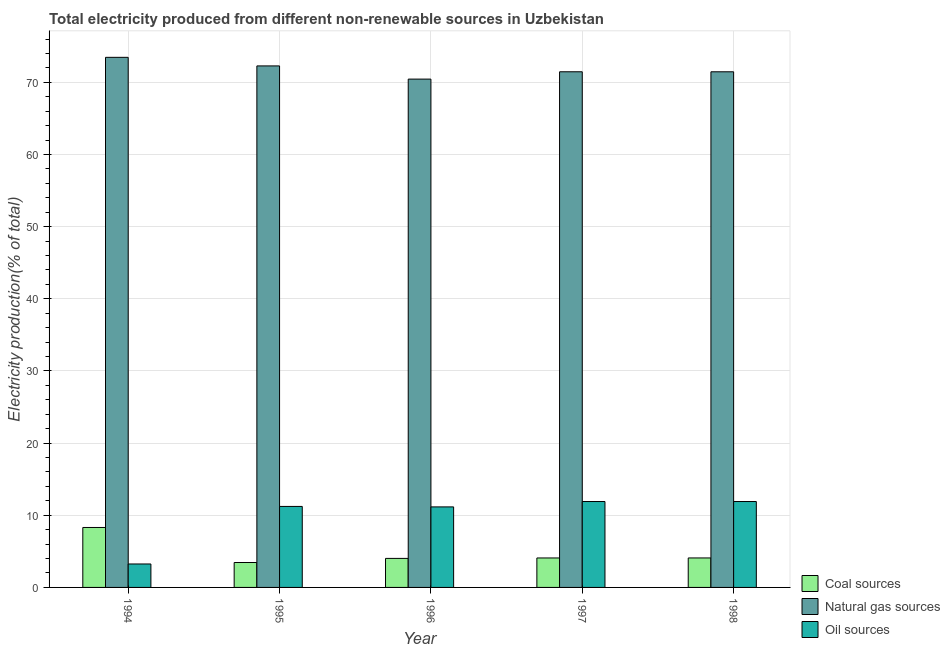How many different coloured bars are there?
Your answer should be compact. 3. How many bars are there on the 4th tick from the right?
Keep it short and to the point. 3. What is the label of the 2nd group of bars from the left?
Your response must be concise. 1995. In how many cases, is the number of bars for a given year not equal to the number of legend labels?
Give a very brief answer. 0. What is the percentage of electricity produced by coal in 1995?
Offer a terse response. 3.45. Across all years, what is the maximum percentage of electricity produced by coal?
Offer a terse response. 8.31. Across all years, what is the minimum percentage of electricity produced by natural gas?
Provide a short and direct response. 70.45. What is the total percentage of electricity produced by oil sources in the graph?
Offer a very short reply. 49.45. What is the difference between the percentage of electricity produced by natural gas in 1995 and that in 1996?
Your response must be concise. 1.83. What is the difference between the percentage of electricity produced by natural gas in 1994 and the percentage of electricity produced by oil sources in 1995?
Provide a short and direct response. 1.19. What is the average percentage of electricity produced by oil sources per year?
Offer a terse response. 9.89. In the year 1995, what is the difference between the percentage of electricity produced by natural gas and percentage of electricity produced by coal?
Keep it short and to the point. 0. In how many years, is the percentage of electricity produced by coal greater than 46 %?
Provide a short and direct response. 0. What is the ratio of the percentage of electricity produced by natural gas in 1994 to that in 1995?
Your answer should be compact. 1.02. What is the difference between the highest and the second highest percentage of electricity produced by oil sources?
Give a very brief answer. 0. What is the difference between the highest and the lowest percentage of electricity produced by natural gas?
Offer a very short reply. 3.02. In how many years, is the percentage of electricity produced by natural gas greater than the average percentage of electricity produced by natural gas taken over all years?
Offer a very short reply. 2. What does the 2nd bar from the left in 1994 represents?
Provide a short and direct response. Natural gas sources. What does the 3rd bar from the right in 1997 represents?
Your response must be concise. Coal sources. Is it the case that in every year, the sum of the percentage of electricity produced by coal and percentage of electricity produced by natural gas is greater than the percentage of electricity produced by oil sources?
Your response must be concise. Yes. How many bars are there?
Offer a very short reply. 15. How many years are there in the graph?
Your answer should be very brief. 5. What is the difference between two consecutive major ticks on the Y-axis?
Your answer should be very brief. 10. Does the graph contain any zero values?
Offer a terse response. No. Does the graph contain grids?
Keep it short and to the point. Yes. Where does the legend appear in the graph?
Your answer should be compact. Bottom right. How are the legend labels stacked?
Offer a very short reply. Vertical. What is the title of the graph?
Offer a terse response. Total electricity produced from different non-renewable sources in Uzbekistan. What is the label or title of the Y-axis?
Your response must be concise. Electricity production(% of total). What is the Electricity production(% of total) in Coal sources in 1994?
Provide a succinct answer. 8.31. What is the Electricity production(% of total) in Natural gas sources in 1994?
Offer a very short reply. 73.47. What is the Electricity production(% of total) in Oil sources in 1994?
Keep it short and to the point. 3.25. What is the Electricity production(% of total) in Coal sources in 1995?
Your answer should be compact. 3.45. What is the Electricity production(% of total) of Natural gas sources in 1995?
Provide a succinct answer. 72.28. What is the Electricity production(% of total) in Oil sources in 1995?
Offer a terse response. 11.23. What is the Electricity production(% of total) in Coal sources in 1996?
Provide a short and direct response. 4.02. What is the Electricity production(% of total) in Natural gas sources in 1996?
Your response must be concise. 70.45. What is the Electricity production(% of total) of Oil sources in 1996?
Ensure brevity in your answer.  11.16. What is the Electricity production(% of total) in Coal sources in 1997?
Offer a very short reply. 4.08. What is the Electricity production(% of total) of Natural gas sources in 1997?
Ensure brevity in your answer.  71.47. What is the Electricity production(% of total) of Oil sources in 1997?
Make the answer very short. 11.91. What is the Electricity production(% of total) in Coal sources in 1998?
Offer a very short reply. 4.08. What is the Electricity production(% of total) in Natural gas sources in 1998?
Give a very brief answer. 71.46. What is the Electricity production(% of total) of Oil sources in 1998?
Ensure brevity in your answer.  11.91. Across all years, what is the maximum Electricity production(% of total) of Coal sources?
Your answer should be compact. 8.31. Across all years, what is the maximum Electricity production(% of total) of Natural gas sources?
Offer a very short reply. 73.47. Across all years, what is the maximum Electricity production(% of total) of Oil sources?
Offer a very short reply. 11.91. Across all years, what is the minimum Electricity production(% of total) in Coal sources?
Ensure brevity in your answer.  3.45. Across all years, what is the minimum Electricity production(% of total) in Natural gas sources?
Offer a very short reply. 70.45. Across all years, what is the minimum Electricity production(% of total) of Oil sources?
Your answer should be very brief. 3.25. What is the total Electricity production(% of total) in Coal sources in the graph?
Provide a succinct answer. 23.96. What is the total Electricity production(% of total) of Natural gas sources in the graph?
Your response must be concise. 359.13. What is the total Electricity production(% of total) in Oil sources in the graph?
Make the answer very short. 49.45. What is the difference between the Electricity production(% of total) in Coal sources in 1994 and that in 1995?
Make the answer very short. 4.86. What is the difference between the Electricity production(% of total) of Natural gas sources in 1994 and that in 1995?
Give a very brief answer. 1.19. What is the difference between the Electricity production(% of total) of Oil sources in 1994 and that in 1995?
Offer a terse response. -7.97. What is the difference between the Electricity production(% of total) of Coal sources in 1994 and that in 1996?
Your response must be concise. 4.29. What is the difference between the Electricity production(% of total) of Natural gas sources in 1994 and that in 1996?
Give a very brief answer. 3.02. What is the difference between the Electricity production(% of total) of Oil sources in 1994 and that in 1996?
Provide a short and direct response. -7.91. What is the difference between the Electricity production(% of total) in Coal sources in 1994 and that in 1997?
Offer a terse response. 4.23. What is the difference between the Electricity production(% of total) in Natural gas sources in 1994 and that in 1997?
Your answer should be very brief. 2. What is the difference between the Electricity production(% of total) of Oil sources in 1994 and that in 1997?
Offer a very short reply. -8.65. What is the difference between the Electricity production(% of total) of Coal sources in 1994 and that in 1998?
Make the answer very short. 4.22. What is the difference between the Electricity production(% of total) of Natural gas sources in 1994 and that in 1998?
Provide a short and direct response. 2. What is the difference between the Electricity production(% of total) of Oil sources in 1994 and that in 1998?
Your answer should be compact. -8.66. What is the difference between the Electricity production(% of total) of Coal sources in 1995 and that in 1996?
Give a very brief answer. -0.57. What is the difference between the Electricity production(% of total) in Natural gas sources in 1995 and that in 1996?
Keep it short and to the point. 1.83. What is the difference between the Electricity production(% of total) of Oil sources in 1995 and that in 1996?
Your answer should be very brief. 0.07. What is the difference between the Electricity production(% of total) in Coal sources in 1995 and that in 1997?
Ensure brevity in your answer.  -0.63. What is the difference between the Electricity production(% of total) in Natural gas sources in 1995 and that in 1997?
Your answer should be very brief. 0.81. What is the difference between the Electricity production(% of total) in Oil sources in 1995 and that in 1997?
Give a very brief answer. -0.68. What is the difference between the Electricity production(% of total) in Coal sources in 1995 and that in 1998?
Make the answer very short. -0.63. What is the difference between the Electricity production(% of total) of Natural gas sources in 1995 and that in 1998?
Make the answer very short. 0.82. What is the difference between the Electricity production(% of total) of Oil sources in 1995 and that in 1998?
Your response must be concise. -0.68. What is the difference between the Electricity production(% of total) in Coal sources in 1996 and that in 1997?
Your answer should be compact. -0.06. What is the difference between the Electricity production(% of total) of Natural gas sources in 1996 and that in 1997?
Keep it short and to the point. -1.02. What is the difference between the Electricity production(% of total) in Oil sources in 1996 and that in 1997?
Make the answer very short. -0.75. What is the difference between the Electricity production(% of total) in Coal sources in 1996 and that in 1998?
Your response must be concise. -0.06. What is the difference between the Electricity production(% of total) of Natural gas sources in 1996 and that in 1998?
Make the answer very short. -1.01. What is the difference between the Electricity production(% of total) of Oil sources in 1996 and that in 1998?
Ensure brevity in your answer.  -0.75. What is the difference between the Electricity production(% of total) in Coal sources in 1997 and that in 1998?
Your response must be concise. -0. What is the difference between the Electricity production(% of total) in Natural gas sources in 1997 and that in 1998?
Ensure brevity in your answer.  0. What is the difference between the Electricity production(% of total) in Oil sources in 1997 and that in 1998?
Keep it short and to the point. -0. What is the difference between the Electricity production(% of total) of Coal sources in 1994 and the Electricity production(% of total) of Natural gas sources in 1995?
Offer a terse response. -63.97. What is the difference between the Electricity production(% of total) in Coal sources in 1994 and the Electricity production(% of total) in Oil sources in 1995?
Offer a very short reply. -2.92. What is the difference between the Electricity production(% of total) of Natural gas sources in 1994 and the Electricity production(% of total) of Oil sources in 1995?
Your answer should be very brief. 62.24. What is the difference between the Electricity production(% of total) of Coal sources in 1994 and the Electricity production(% of total) of Natural gas sources in 1996?
Give a very brief answer. -62.14. What is the difference between the Electricity production(% of total) in Coal sources in 1994 and the Electricity production(% of total) in Oil sources in 1996?
Offer a terse response. -2.85. What is the difference between the Electricity production(% of total) of Natural gas sources in 1994 and the Electricity production(% of total) of Oil sources in 1996?
Offer a terse response. 62.31. What is the difference between the Electricity production(% of total) of Coal sources in 1994 and the Electricity production(% of total) of Natural gas sources in 1997?
Your answer should be very brief. -63.16. What is the difference between the Electricity production(% of total) of Coal sources in 1994 and the Electricity production(% of total) of Oil sources in 1997?
Provide a succinct answer. -3.6. What is the difference between the Electricity production(% of total) of Natural gas sources in 1994 and the Electricity production(% of total) of Oil sources in 1997?
Offer a terse response. 61.56. What is the difference between the Electricity production(% of total) in Coal sources in 1994 and the Electricity production(% of total) in Natural gas sources in 1998?
Your answer should be very brief. -63.15. What is the difference between the Electricity production(% of total) in Coal sources in 1994 and the Electricity production(% of total) in Oil sources in 1998?
Your answer should be compact. -3.6. What is the difference between the Electricity production(% of total) in Natural gas sources in 1994 and the Electricity production(% of total) in Oil sources in 1998?
Your answer should be very brief. 61.56. What is the difference between the Electricity production(% of total) in Coal sources in 1995 and the Electricity production(% of total) in Natural gas sources in 1996?
Provide a succinct answer. -67. What is the difference between the Electricity production(% of total) in Coal sources in 1995 and the Electricity production(% of total) in Oil sources in 1996?
Give a very brief answer. -7.71. What is the difference between the Electricity production(% of total) in Natural gas sources in 1995 and the Electricity production(% of total) in Oil sources in 1996?
Provide a succinct answer. 61.12. What is the difference between the Electricity production(% of total) in Coal sources in 1995 and the Electricity production(% of total) in Natural gas sources in 1997?
Keep it short and to the point. -68.01. What is the difference between the Electricity production(% of total) in Coal sources in 1995 and the Electricity production(% of total) in Oil sources in 1997?
Make the answer very short. -8.45. What is the difference between the Electricity production(% of total) of Natural gas sources in 1995 and the Electricity production(% of total) of Oil sources in 1997?
Offer a terse response. 60.37. What is the difference between the Electricity production(% of total) in Coal sources in 1995 and the Electricity production(% of total) in Natural gas sources in 1998?
Offer a very short reply. -68.01. What is the difference between the Electricity production(% of total) in Coal sources in 1995 and the Electricity production(% of total) in Oil sources in 1998?
Ensure brevity in your answer.  -8.45. What is the difference between the Electricity production(% of total) in Natural gas sources in 1995 and the Electricity production(% of total) in Oil sources in 1998?
Give a very brief answer. 60.37. What is the difference between the Electricity production(% of total) of Coal sources in 1996 and the Electricity production(% of total) of Natural gas sources in 1997?
Make the answer very short. -67.44. What is the difference between the Electricity production(% of total) of Coal sources in 1996 and the Electricity production(% of total) of Oil sources in 1997?
Offer a terse response. -7.88. What is the difference between the Electricity production(% of total) in Natural gas sources in 1996 and the Electricity production(% of total) in Oil sources in 1997?
Provide a short and direct response. 58.55. What is the difference between the Electricity production(% of total) of Coal sources in 1996 and the Electricity production(% of total) of Natural gas sources in 1998?
Ensure brevity in your answer.  -67.44. What is the difference between the Electricity production(% of total) in Coal sources in 1996 and the Electricity production(% of total) in Oil sources in 1998?
Your response must be concise. -7.88. What is the difference between the Electricity production(% of total) of Natural gas sources in 1996 and the Electricity production(% of total) of Oil sources in 1998?
Offer a very short reply. 58.54. What is the difference between the Electricity production(% of total) of Coal sources in 1997 and the Electricity production(% of total) of Natural gas sources in 1998?
Provide a succinct answer. -67.38. What is the difference between the Electricity production(% of total) of Coal sources in 1997 and the Electricity production(% of total) of Oil sources in 1998?
Give a very brief answer. -7.82. What is the difference between the Electricity production(% of total) of Natural gas sources in 1997 and the Electricity production(% of total) of Oil sources in 1998?
Offer a terse response. 59.56. What is the average Electricity production(% of total) of Coal sources per year?
Offer a very short reply. 4.79. What is the average Electricity production(% of total) of Natural gas sources per year?
Make the answer very short. 71.83. What is the average Electricity production(% of total) of Oil sources per year?
Provide a short and direct response. 9.89. In the year 1994, what is the difference between the Electricity production(% of total) in Coal sources and Electricity production(% of total) in Natural gas sources?
Make the answer very short. -65.16. In the year 1994, what is the difference between the Electricity production(% of total) in Coal sources and Electricity production(% of total) in Oil sources?
Ensure brevity in your answer.  5.06. In the year 1994, what is the difference between the Electricity production(% of total) in Natural gas sources and Electricity production(% of total) in Oil sources?
Your response must be concise. 70.22. In the year 1995, what is the difference between the Electricity production(% of total) in Coal sources and Electricity production(% of total) in Natural gas sources?
Keep it short and to the point. -68.83. In the year 1995, what is the difference between the Electricity production(% of total) of Coal sources and Electricity production(% of total) of Oil sources?
Provide a short and direct response. -7.77. In the year 1995, what is the difference between the Electricity production(% of total) of Natural gas sources and Electricity production(% of total) of Oil sources?
Provide a succinct answer. 61.05. In the year 1996, what is the difference between the Electricity production(% of total) in Coal sources and Electricity production(% of total) in Natural gas sources?
Your answer should be very brief. -66.43. In the year 1996, what is the difference between the Electricity production(% of total) in Coal sources and Electricity production(% of total) in Oil sources?
Give a very brief answer. -7.14. In the year 1996, what is the difference between the Electricity production(% of total) in Natural gas sources and Electricity production(% of total) in Oil sources?
Your answer should be very brief. 59.29. In the year 1997, what is the difference between the Electricity production(% of total) in Coal sources and Electricity production(% of total) in Natural gas sources?
Provide a short and direct response. -67.38. In the year 1997, what is the difference between the Electricity production(% of total) in Coal sources and Electricity production(% of total) in Oil sources?
Provide a short and direct response. -7.82. In the year 1997, what is the difference between the Electricity production(% of total) in Natural gas sources and Electricity production(% of total) in Oil sources?
Provide a succinct answer. 59.56. In the year 1998, what is the difference between the Electricity production(% of total) in Coal sources and Electricity production(% of total) in Natural gas sources?
Provide a short and direct response. -67.38. In the year 1998, what is the difference between the Electricity production(% of total) of Coal sources and Electricity production(% of total) of Oil sources?
Your answer should be compact. -7.82. In the year 1998, what is the difference between the Electricity production(% of total) in Natural gas sources and Electricity production(% of total) in Oil sources?
Provide a short and direct response. 59.56. What is the ratio of the Electricity production(% of total) in Coal sources in 1994 to that in 1995?
Make the answer very short. 2.41. What is the ratio of the Electricity production(% of total) in Natural gas sources in 1994 to that in 1995?
Provide a succinct answer. 1.02. What is the ratio of the Electricity production(% of total) of Oil sources in 1994 to that in 1995?
Provide a short and direct response. 0.29. What is the ratio of the Electricity production(% of total) in Coal sources in 1994 to that in 1996?
Your answer should be very brief. 2.07. What is the ratio of the Electricity production(% of total) in Natural gas sources in 1994 to that in 1996?
Make the answer very short. 1.04. What is the ratio of the Electricity production(% of total) in Oil sources in 1994 to that in 1996?
Give a very brief answer. 0.29. What is the ratio of the Electricity production(% of total) of Coal sources in 1994 to that in 1997?
Give a very brief answer. 2.03. What is the ratio of the Electricity production(% of total) in Natural gas sources in 1994 to that in 1997?
Your response must be concise. 1.03. What is the ratio of the Electricity production(% of total) of Oil sources in 1994 to that in 1997?
Offer a very short reply. 0.27. What is the ratio of the Electricity production(% of total) of Coal sources in 1994 to that in 1998?
Give a very brief answer. 2.03. What is the ratio of the Electricity production(% of total) in Natural gas sources in 1994 to that in 1998?
Make the answer very short. 1.03. What is the ratio of the Electricity production(% of total) in Oil sources in 1994 to that in 1998?
Make the answer very short. 0.27. What is the ratio of the Electricity production(% of total) of Coal sources in 1995 to that in 1996?
Offer a very short reply. 0.86. What is the ratio of the Electricity production(% of total) of Oil sources in 1995 to that in 1996?
Offer a very short reply. 1.01. What is the ratio of the Electricity production(% of total) of Coal sources in 1995 to that in 1997?
Offer a terse response. 0.85. What is the ratio of the Electricity production(% of total) of Natural gas sources in 1995 to that in 1997?
Offer a terse response. 1.01. What is the ratio of the Electricity production(% of total) in Oil sources in 1995 to that in 1997?
Your answer should be very brief. 0.94. What is the ratio of the Electricity production(% of total) of Coal sources in 1995 to that in 1998?
Provide a succinct answer. 0.85. What is the ratio of the Electricity production(% of total) of Natural gas sources in 1995 to that in 1998?
Offer a terse response. 1.01. What is the ratio of the Electricity production(% of total) of Oil sources in 1995 to that in 1998?
Ensure brevity in your answer.  0.94. What is the ratio of the Electricity production(% of total) of Coal sources in 1996 to that in 1997?
Make the answer very short. 0.98. What is the ratio of the Electricity production(% of total) of Natural gas sources in 1996 to that in 1997?
Your answer should be compact. 0.99. What is the ratio of the Electricity production(% of total) in Oil sources in 1996 to that in 1997?
Offer a terse response. 0.94. What is the ratio of the Electricity production(% of total) of Coal sources in 1996 to that in 1998?
Offer a very short reply. 0.98. What is the ratio of the Electricity production(% of total) of Natural gas sources in 1996 to that in 1998?
Make the answer very short. 0.99. What is the ratio of the Electricity production(% of total) in Oil sources in 1996 to that in 1998?
Your response must be concise. 0.94. What is the ratio of the Electricity production(% of total) of Natural gas sources in 1997 to that in 1998?
Offer a very short reply. 1. What is the ratio of the Electricity production(% of total) of Oil sources in 1997 to that in 1998?
Your response must be concise. 1. What is the difference between the highest and the second highest Electricity production(% of total) of Coal sources?
Offer a very short reply. 4.22. What is the difference between the highest and the second highest Electricity production(% of total) in Natural gas sources?
Your answer should be very brief. 1.19. What is the difference between the highest and the second highest Electricity production(% of total) in Oil sources?
Your answer should be compact. 0. What is the difference between the highest and the lowest Electricity production(% of total) in Coal sources?
Provide a succinct answer. 4.86. What is the difference between the highest and the lowest Electricity production(% of total) in Natural gas sources?
Make the answer very short. 3.02. What is the difference between the highest and the lowest Electricity production(% of total) of Oil sources?
Your response must be concise. 8.66. 